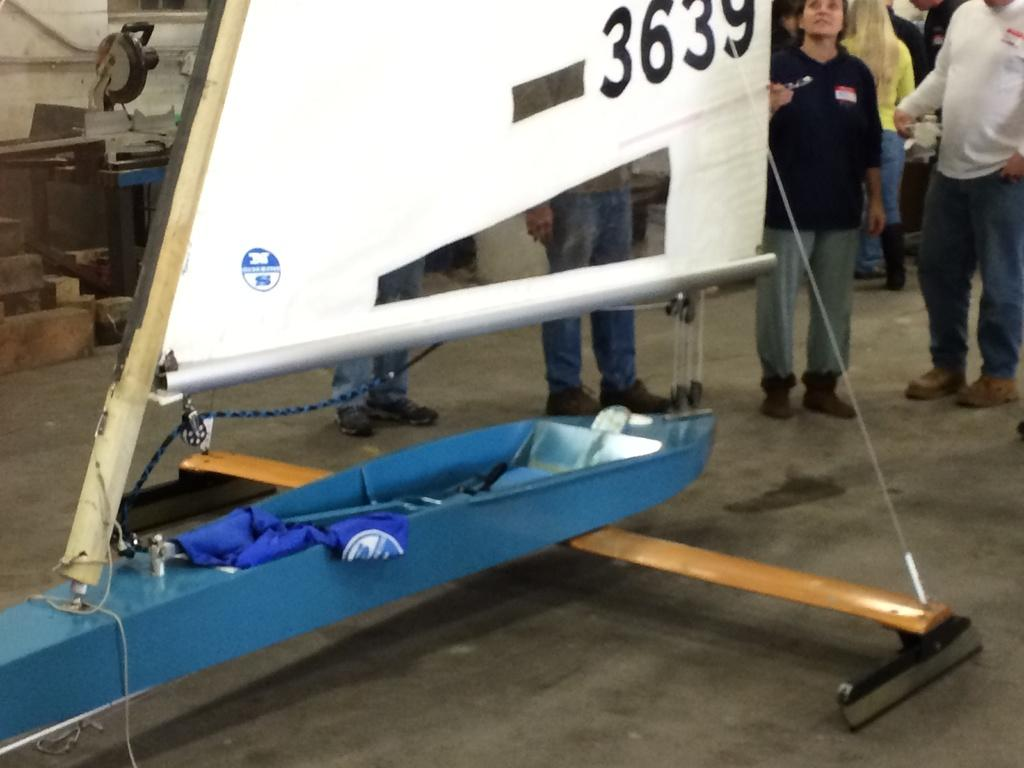<image>
Write a terse but informative summary of the picture. A small, slender boat with a sail numbered 3639 is being viewed by some people. 